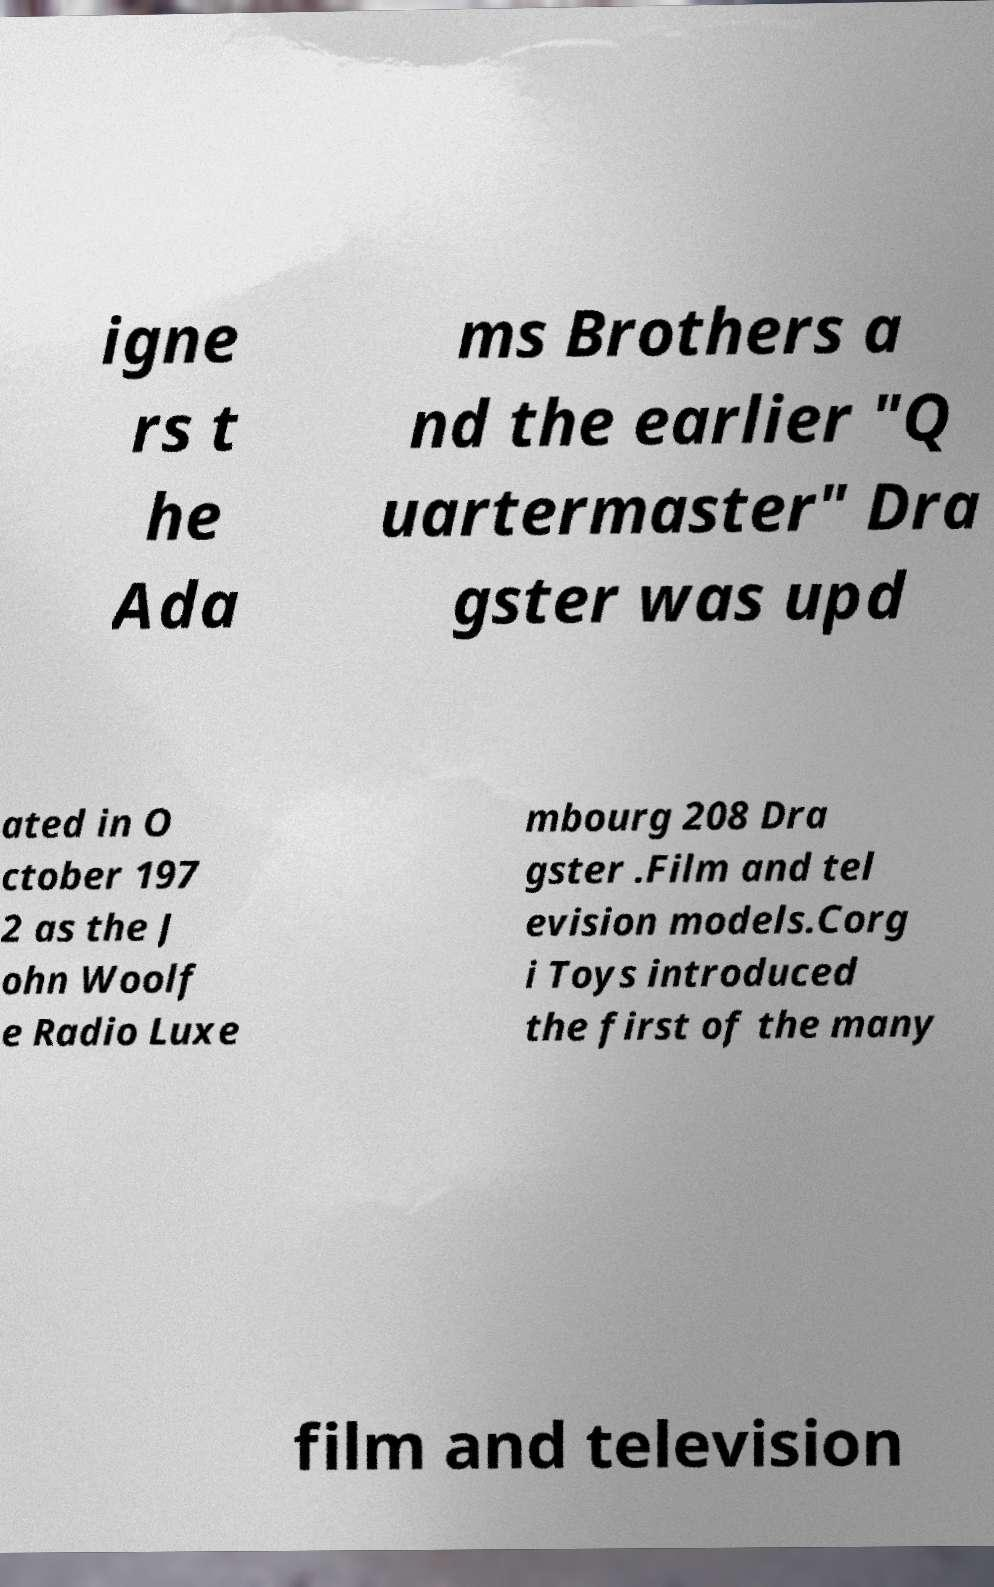Can you read and provide the text displayed in the image?This photo seems to have some interesting text. Can you extract and type it out for me? igne rs t he Ada ms Brothers a nd the earlier "Q uartermaster" Dra gster was upd ated in O ctober 197 2 as the J ohn Woolf e Radio Luxe mbourg 208 Dra gster .Film and tel evision models.Corg i Toys introduced the first of the many film and television 